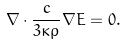Convert formula to latex. <formula><loc_0><loc_0><loc_500><loc_500>\nabla \cdot \frac { c } { 3 \kappa \rho } \nabla E = 0 .</formula> 